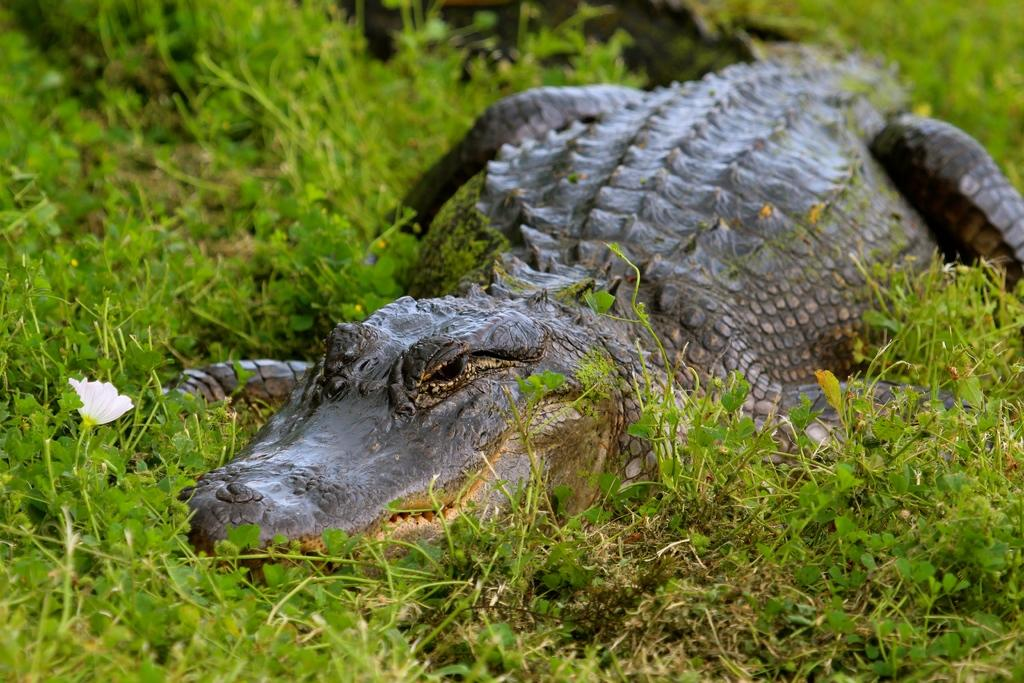What type of animal is in the image? There is a crocodile in the image. What type of vegetation is in the image? There is grass in the image. What type of plant is in the image? There is a white flower in the image. How many bikes are parked next to the crocodile in the image? There are no bikes present in the image. 